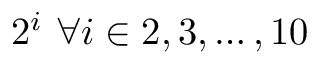<formula> <loc_0><loc_0><loc_500><loc_500>2 ^ { i } \forall i \in 2 , 3 , \dots , 1 0</formula> 